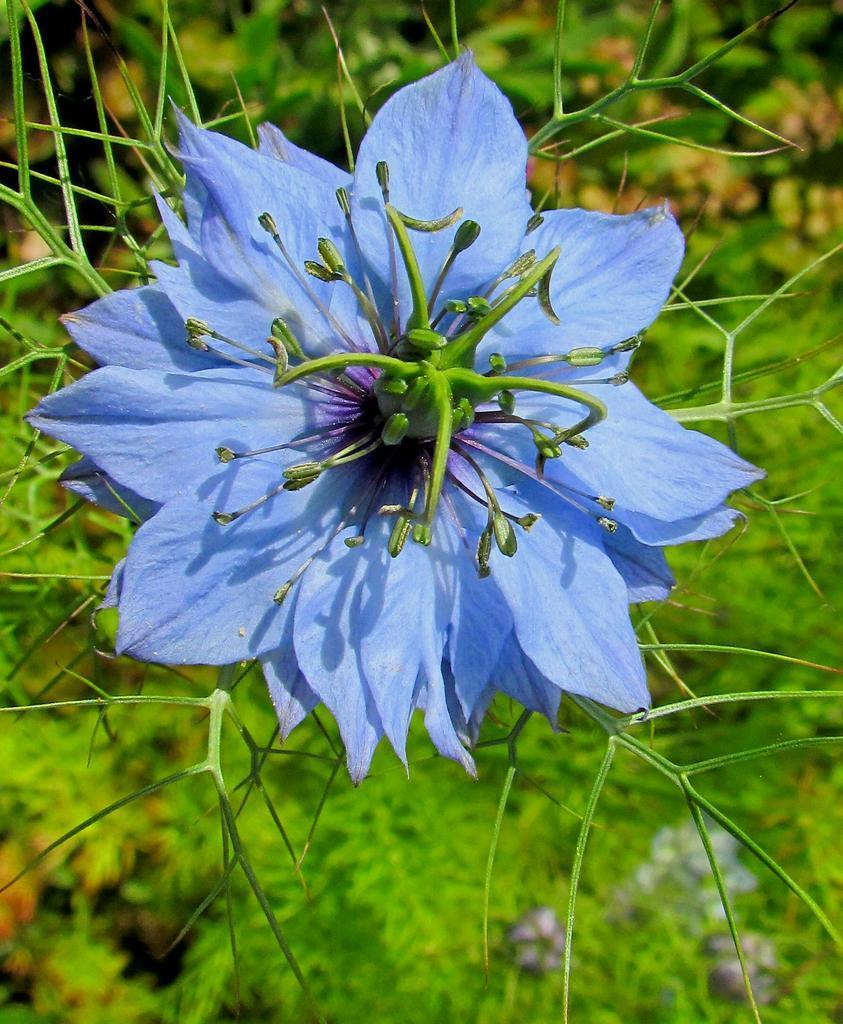Describe this image in one or two sentences. In the picture I can see flower to the plant, behind we can see few plants. 